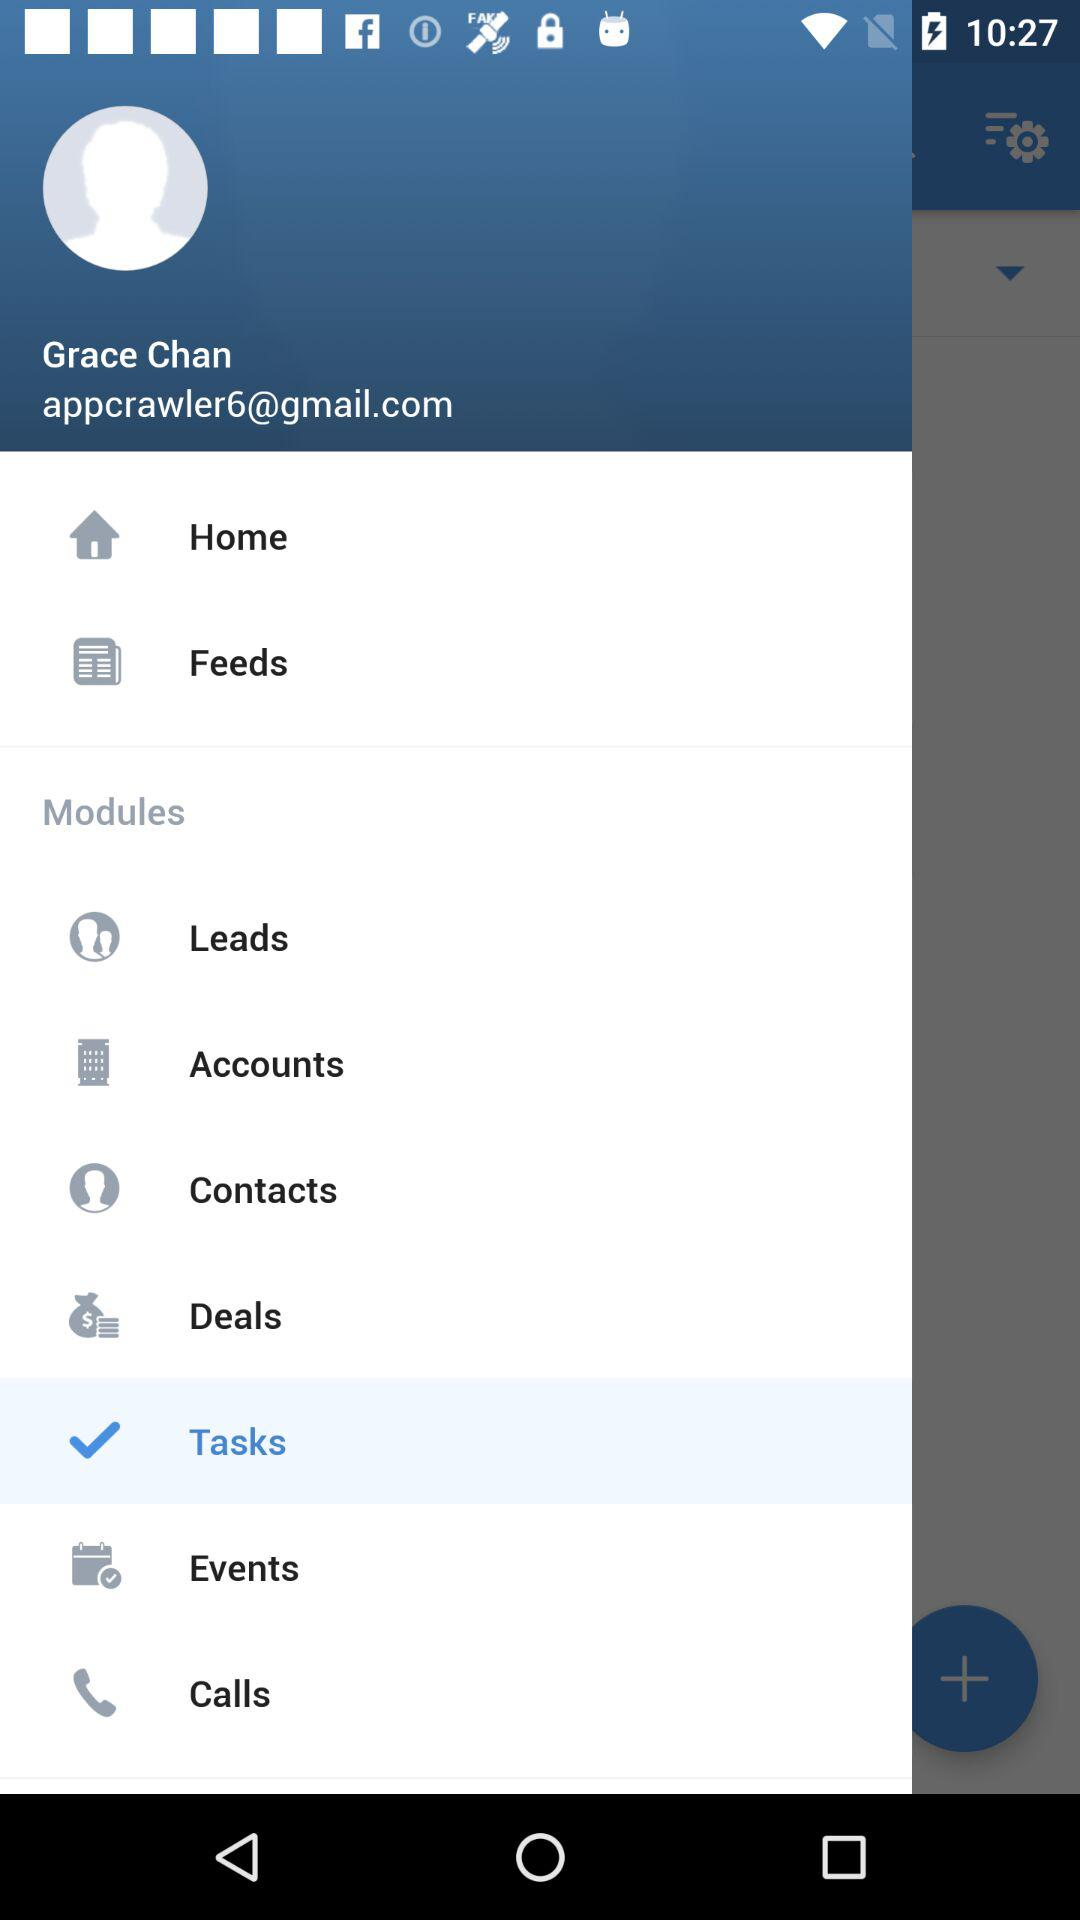What is the name of the user? The name of the user is Grace Chan. 